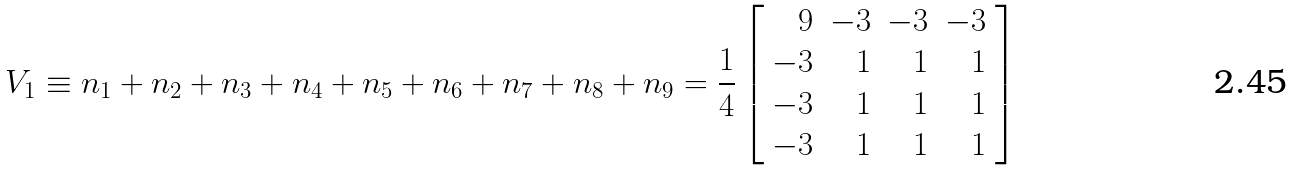Convert formula to latex. <formula><loc_0><loc_0><loc_500><loc_500>V _ { 1 } \equiv n _ { 1 } + n _ { 2 } + n _ { 3 } + n _ { 4 } + n _ { 5 } + n _ { 6 } + n _ { 7 } + n _ { 8 } + n _ { 9 } = \frac { 1 } { 4 } \left [ \begin{array} { r r r r } 9 & - 3 & - 3 & - 3 \\ - 3 & 1 & 1 & 1 \\ - 3 & 1 & 1 & 1 \\ - 3 & 1 & 1 & 1 \end{array} \right ]</formula> 